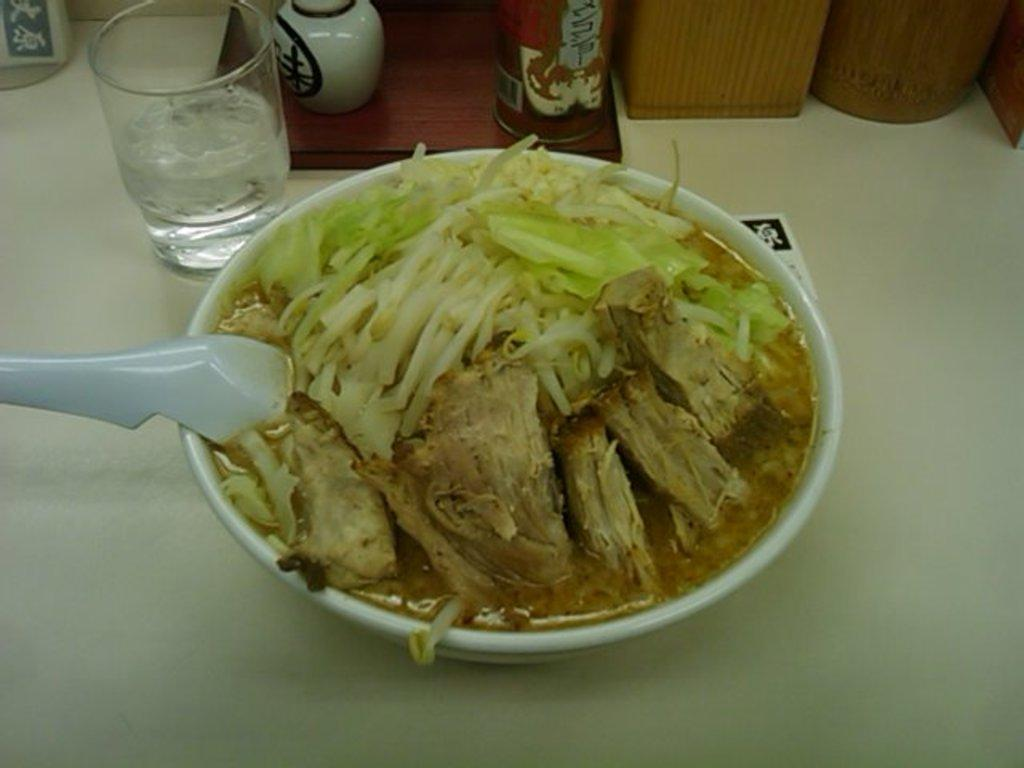What is in the bowl that is visible in the image? There is a bowl with food in the image. What utensil is present in the image? There is a spoon in the image. What type of container is visible in the image? There is a glass in the image. What is the surface on which objects are placed in the image? There are objects on a platform in the image. What type of bait is being used to catch fish in the image? There is no mention of fish or bait in the image; it only features a bowl with food, a spoon, a glass, and objects on a platform. 